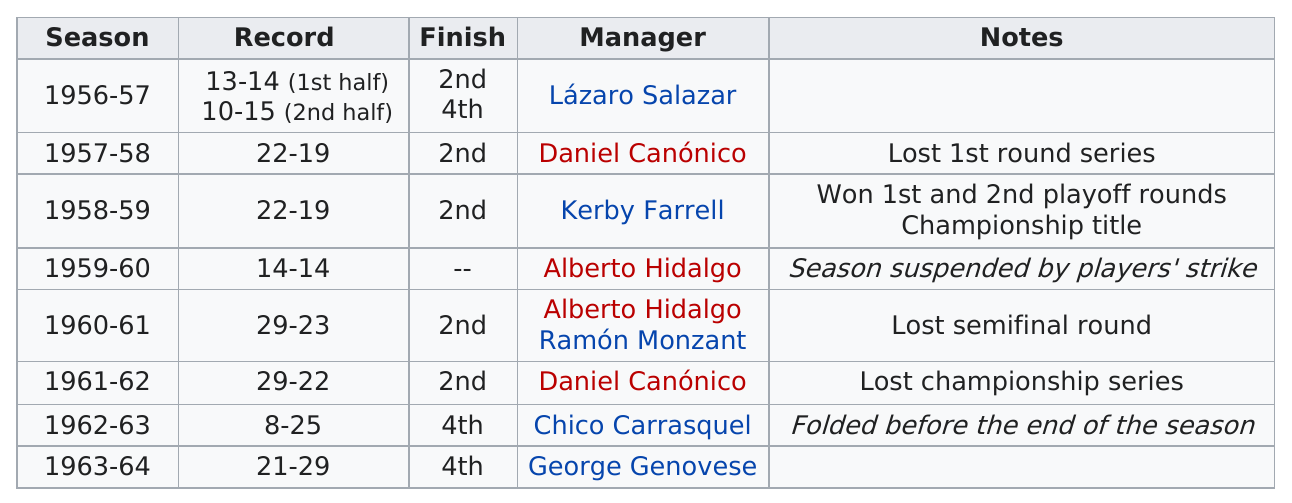Specify some key components in this picture. They had three fourth place finishes. There are fewer than 12 managers on the list. The 1962-1963 season had the least amount of wins out of all seasons. The team won their least amount of games in the year 1962-63. The team did not finish the same as they did in 1956. 